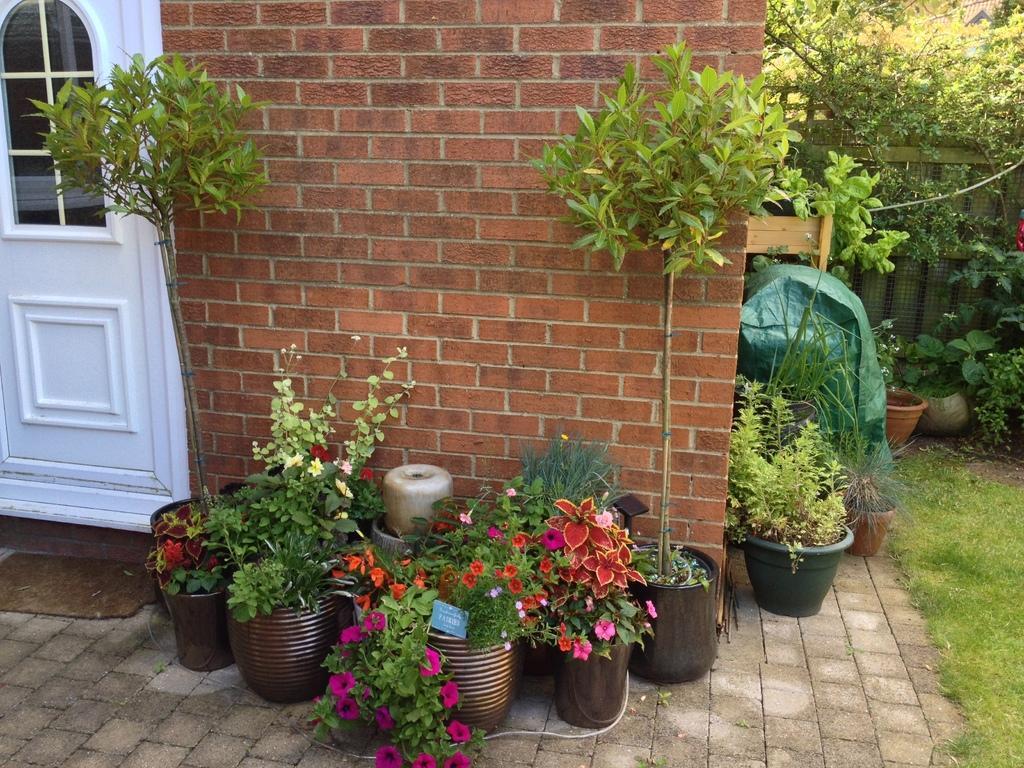Describe this image in one or two sentences. There are plant pots are present at the bottom of this image. We can see a wall in the background. There is a door on the left side of this image. We can see trees and a grassy land on the right side of this image. 